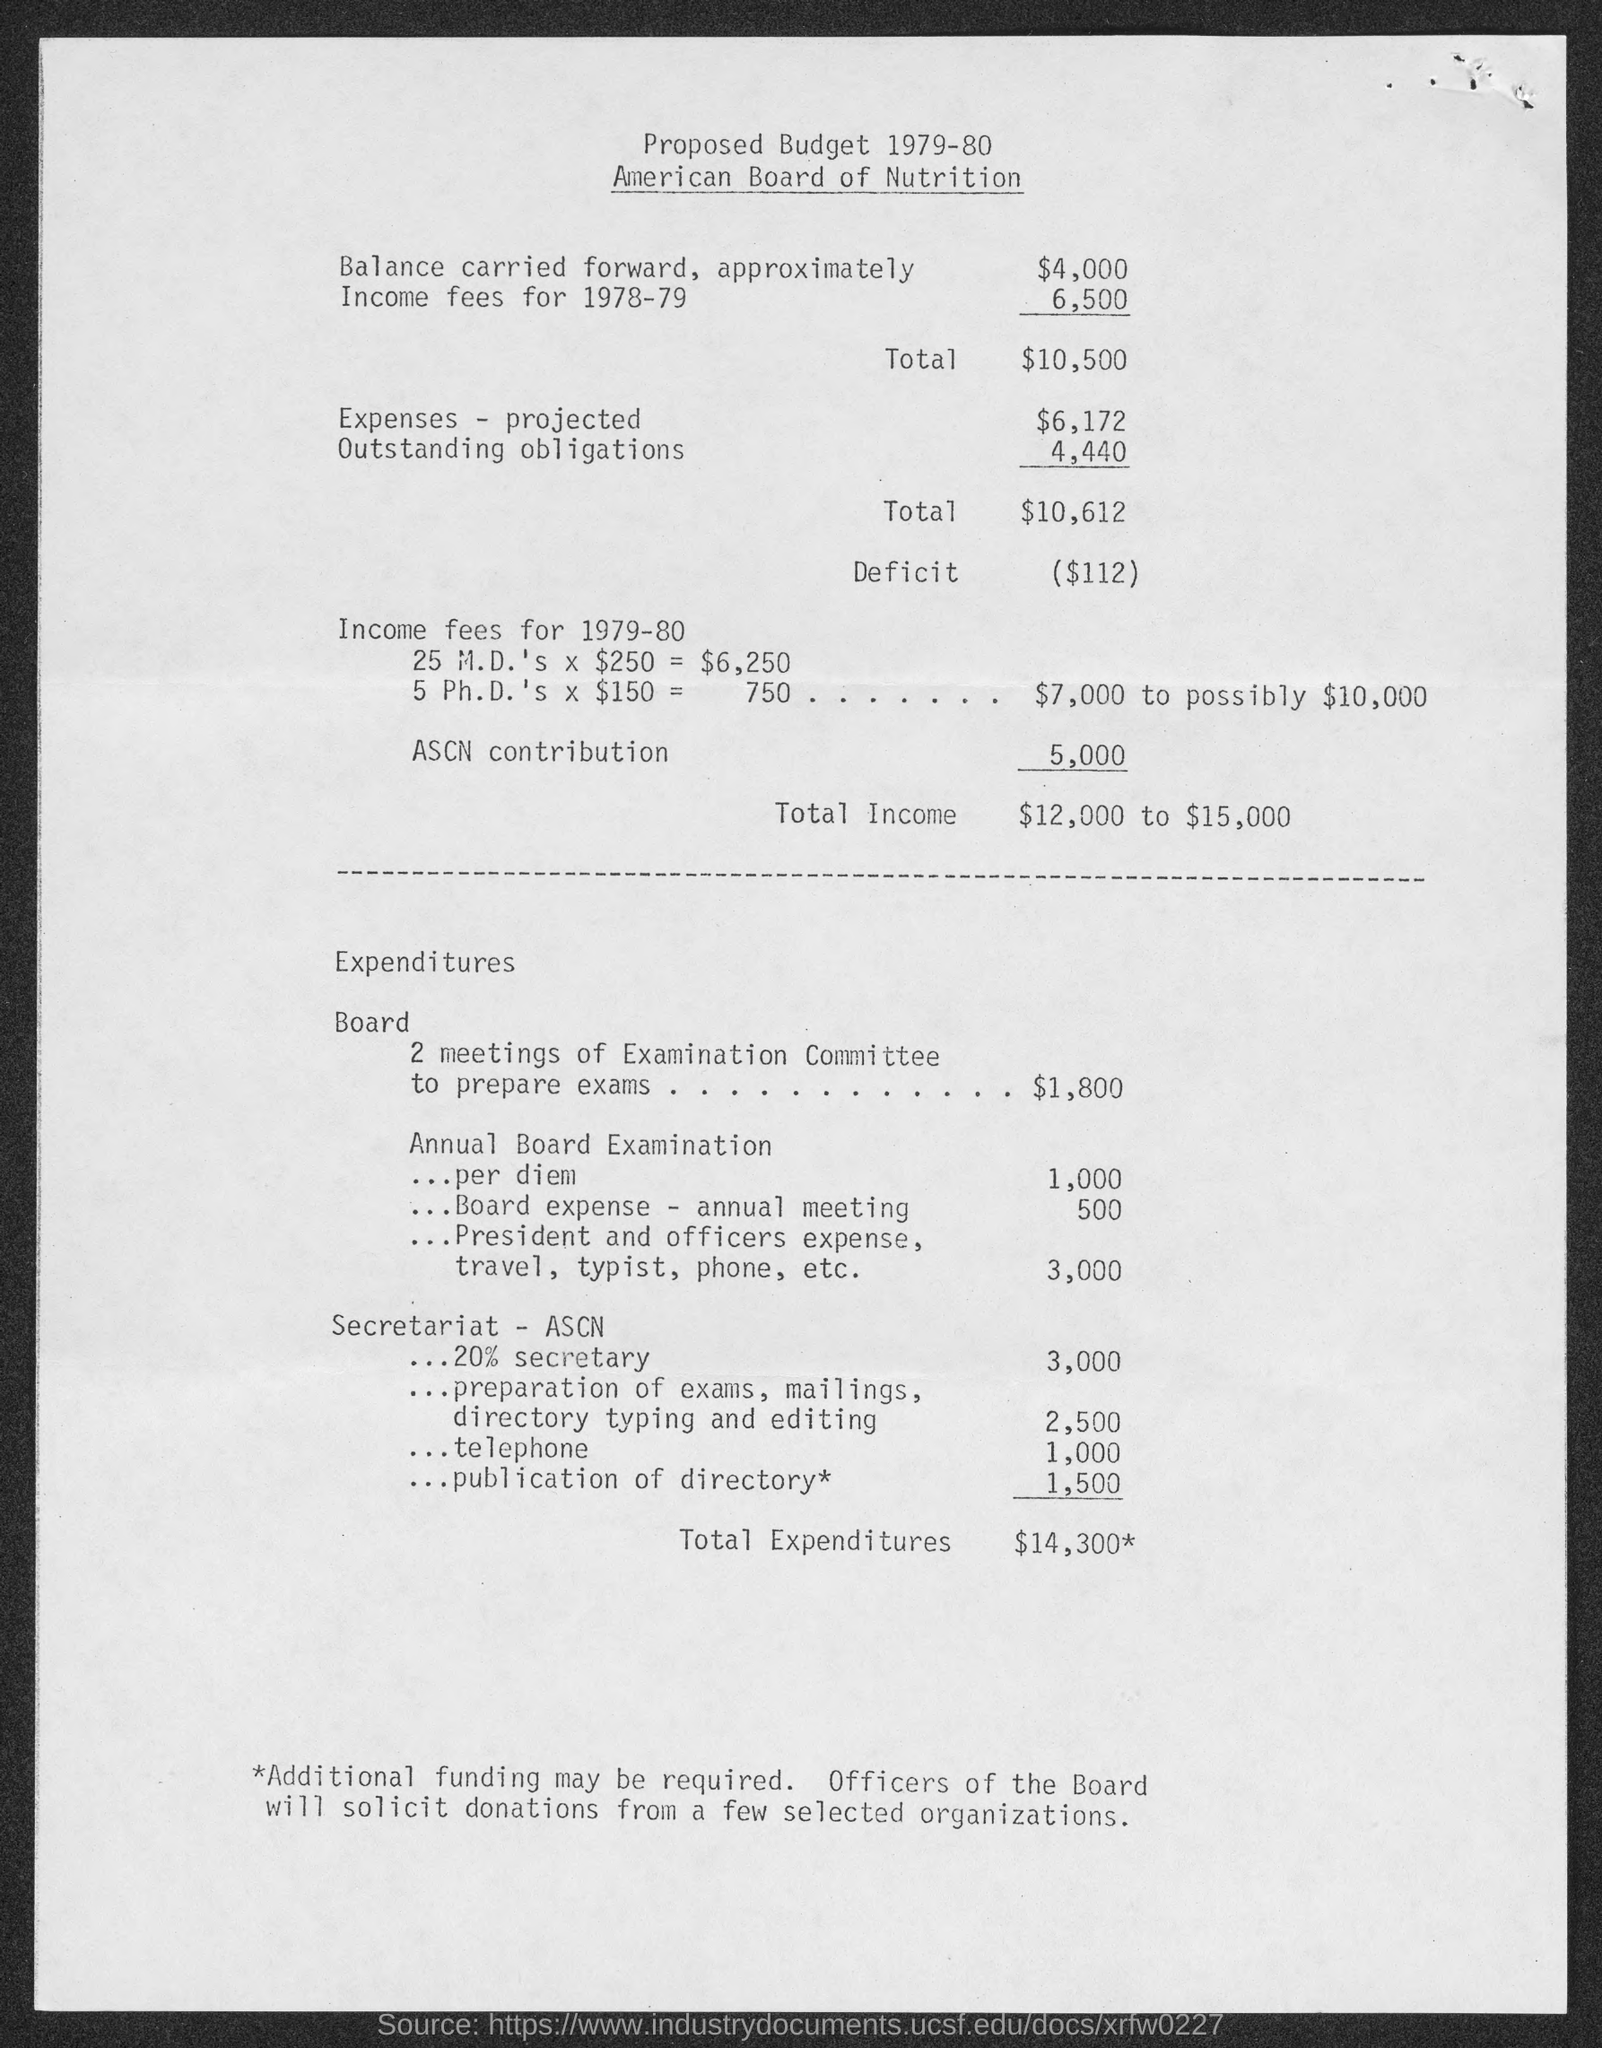Identify some key points in this picture. The projected amount of expenses is $6,172. The total income ranges from $12,000 to $15,000. The balance carried forward approximately is approximately $4,000. The deficit amount is $112. 